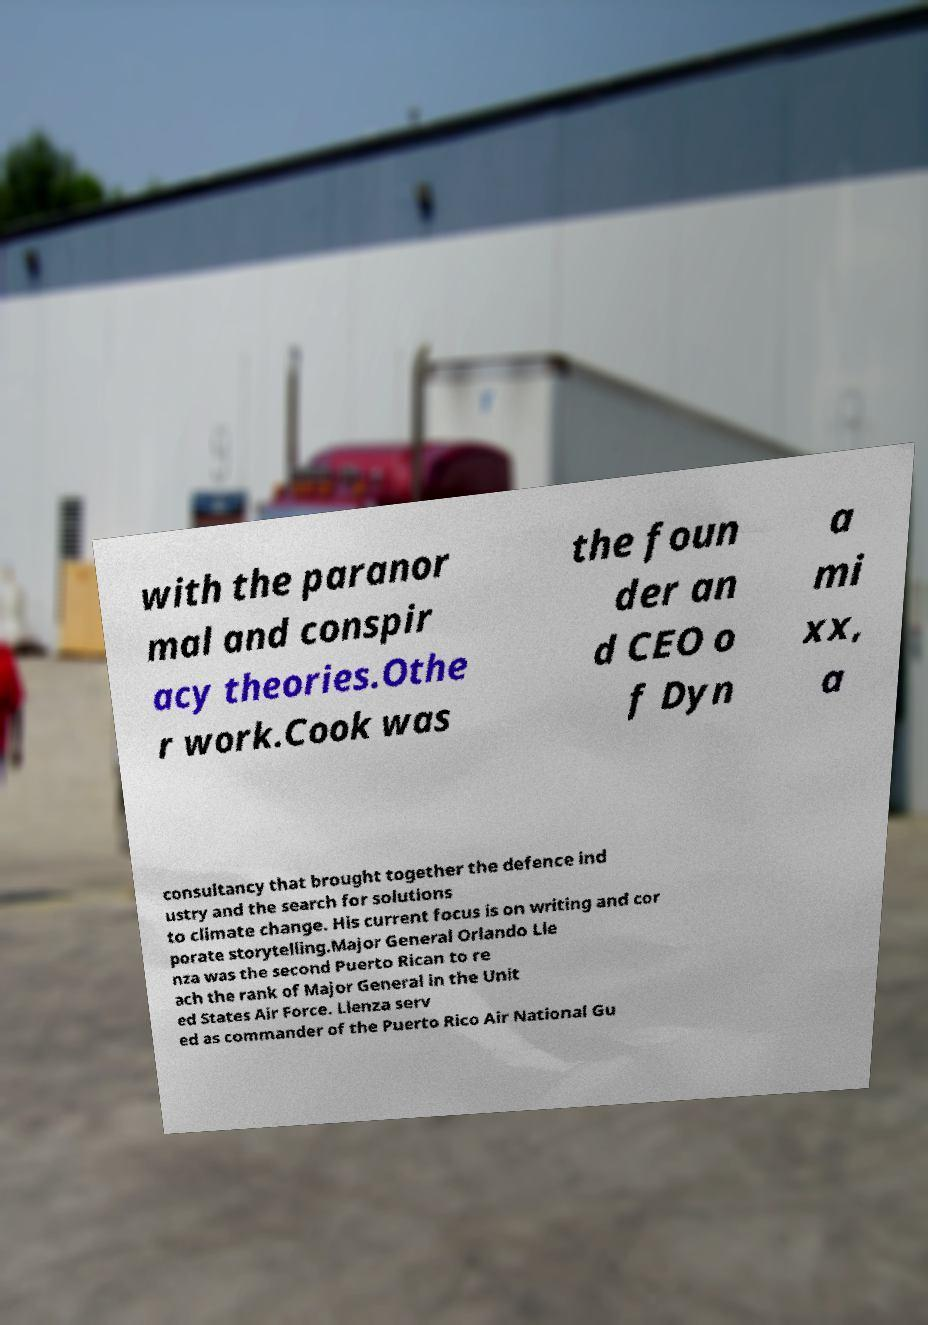Can you accurately transcribe the text from the provided image for me? with the paranor mal and conspir acy theories.Othe r work.Cook was the foun der an d CEO o f Dyn a mi xx, a consultancy that brought together the defence ind ustry and the search for solutions to climate change. His current focus is on writing and cor porate storytelling.Major General Orlando Lle nza was the second Puerto Rican to re ach the rank of Major General in the Unit ed States Air Force. Llenza serv ed as commander of the Puerto Rico Air National Gu 